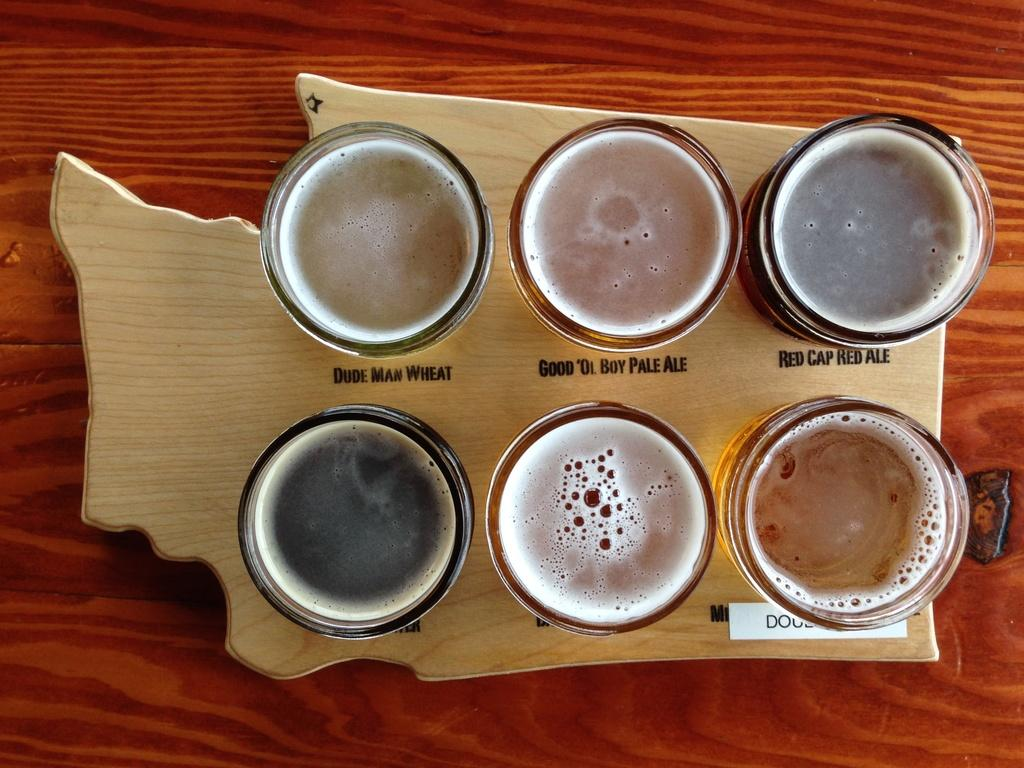What is on the wooden table in the image? There is a plate on the wooden table. What is on the plate? There are six glasses on the plate. What is inside the glasses? The glasses contain juice. Is there any writing or design on the plate? Yes, there is some text on the plate. What type of picture is hanging on the wall behind the plate? There is no wall or picture visible in the image; it only shows a plate with six glasses containing juice on a wooden table. 